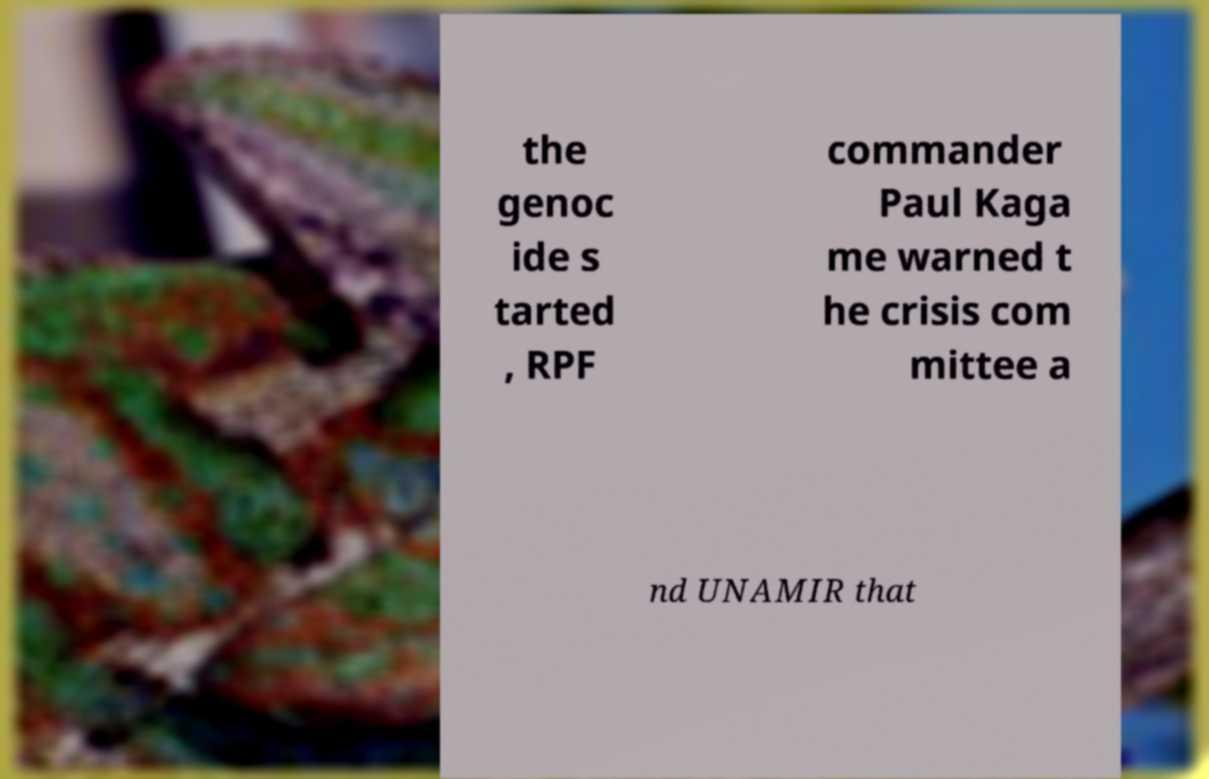There's text embedded in this image that I need extracted. Can you transcribe it verbatim? the genoc ide s tarted , RPF commander Paul Kaga me warned t he crisis com mittee a nd UNAMIR that 